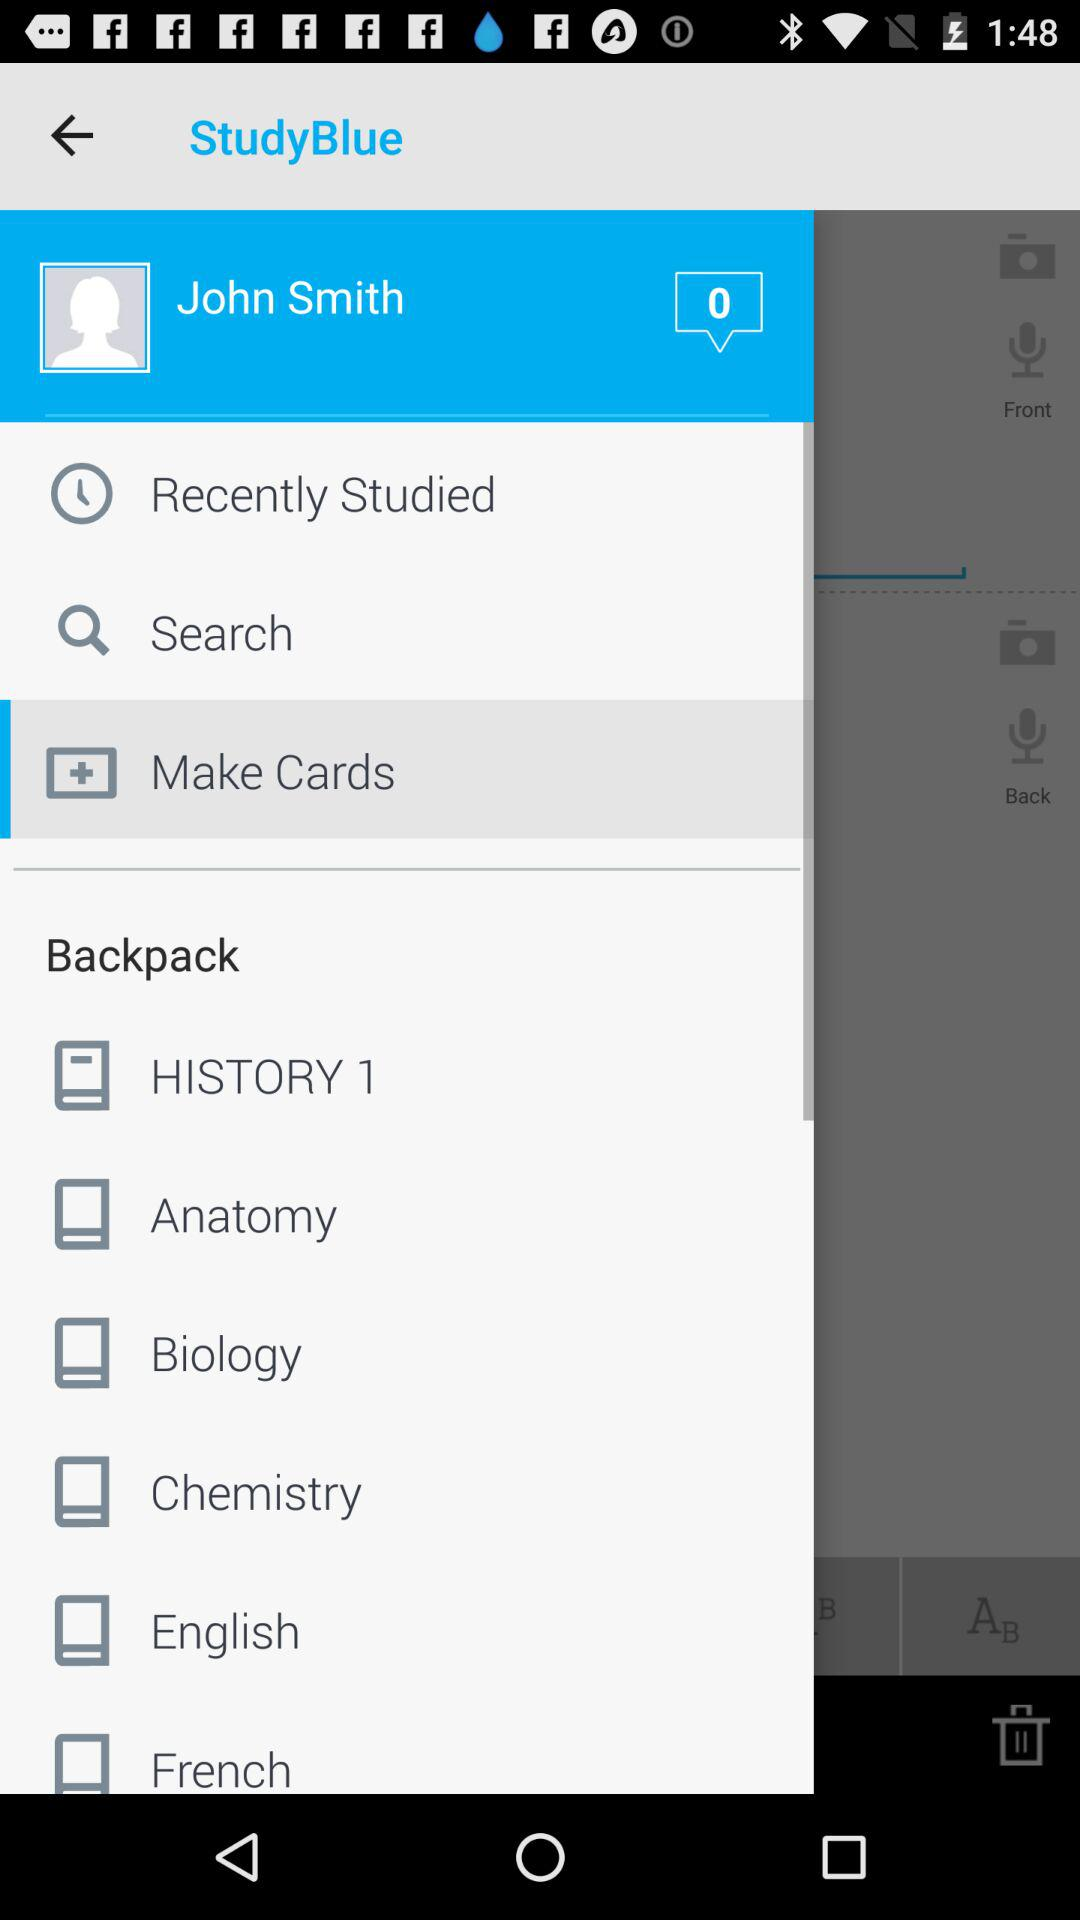What is John Smith's contact email?
When the provided information is insufficient, respond with <no answer>. <no answer> 